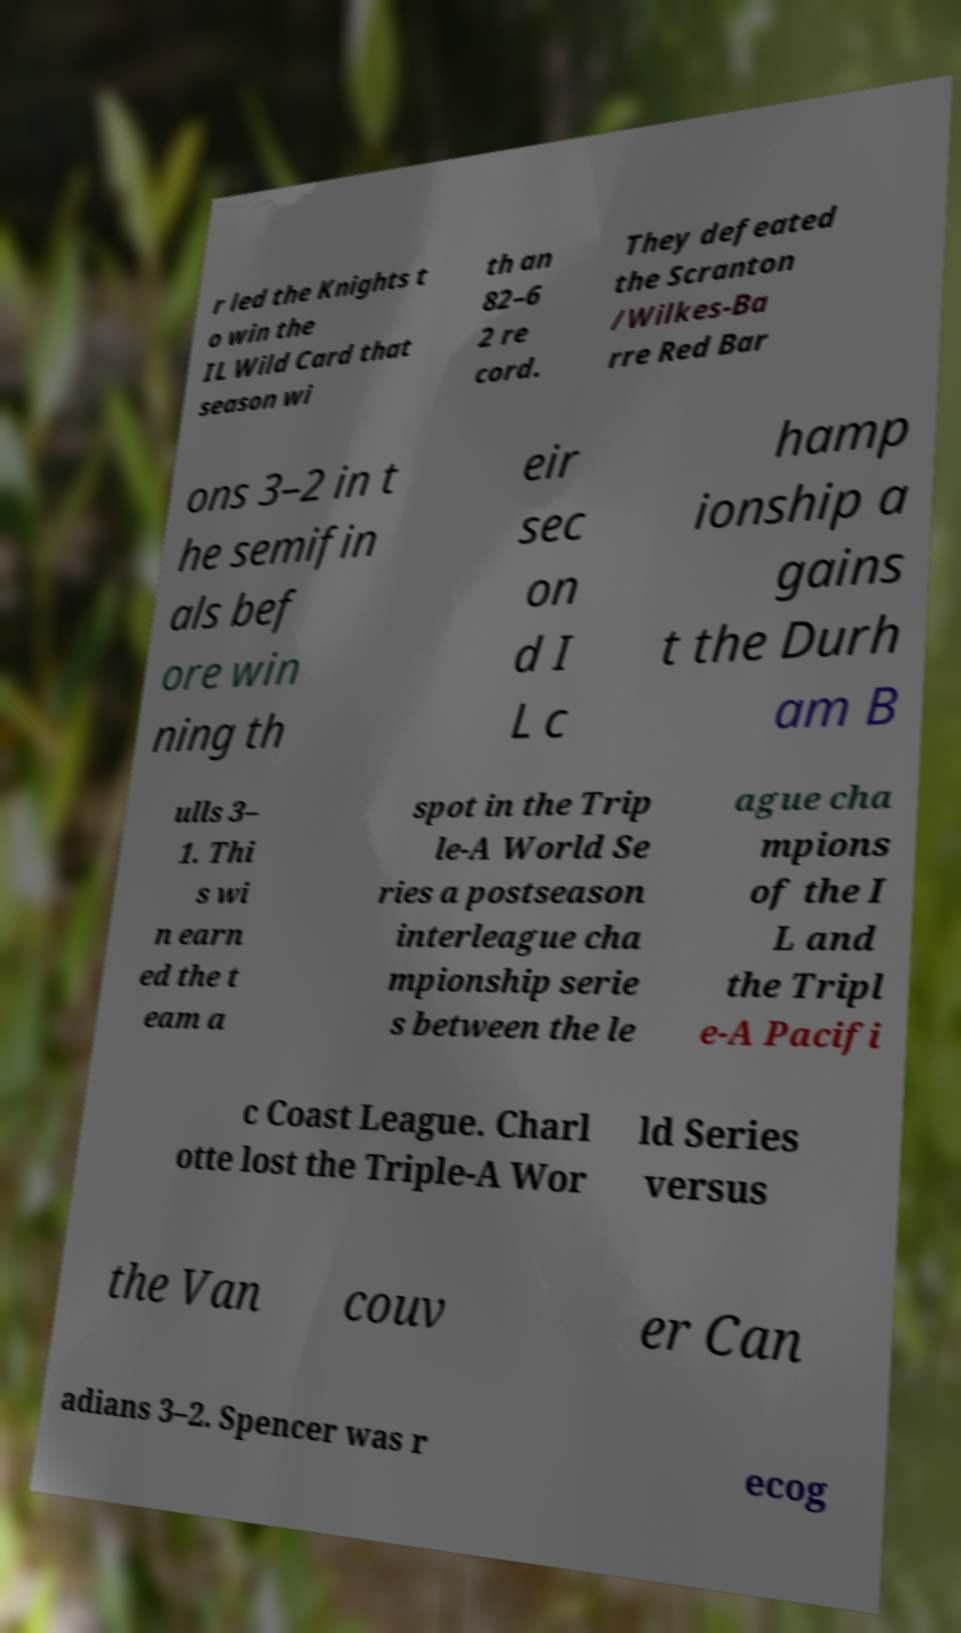Can you accurately transcribe the text from the provided image for me? r led the Knights t o win the IL Wild Card that season wi th an 82–6 2 re cord. They defeated the Scranton /Wilkes-Ba rre Red Bar ons 3–2 in t he semifin als bef ore win ning th eir sec on d I L c hamp ionship a gains t the Durh am B ulls 3– 1. Thi s wi n earn ed the t eam a spot in the Trip le-A World Se ries a postseason interleague cha mpionship serie s between the le ague cha mpions of the I L and the Tripl e-A Pacifi c Coast League. Charl otte lost the Triple-A Wor ld Series versus the Van couv er Can adians 3–2. Spencer was r ecog 